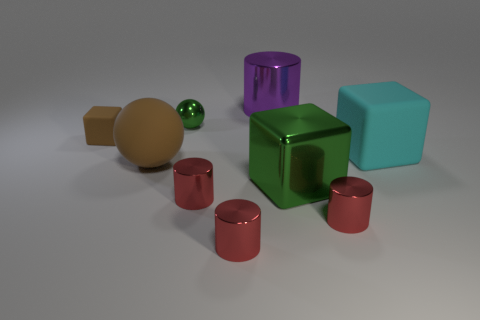Can you describe the arrangement of the objects on the table? The objects are arranged somewhat scattered across a flat surface. They comprise a variety of shapes and colors, including cylinders, cubes, and spheres, creating a visually stimulating array. Each element seems to be placed with a sense of randomness, yet the overall scene feels balanced and intentional. 